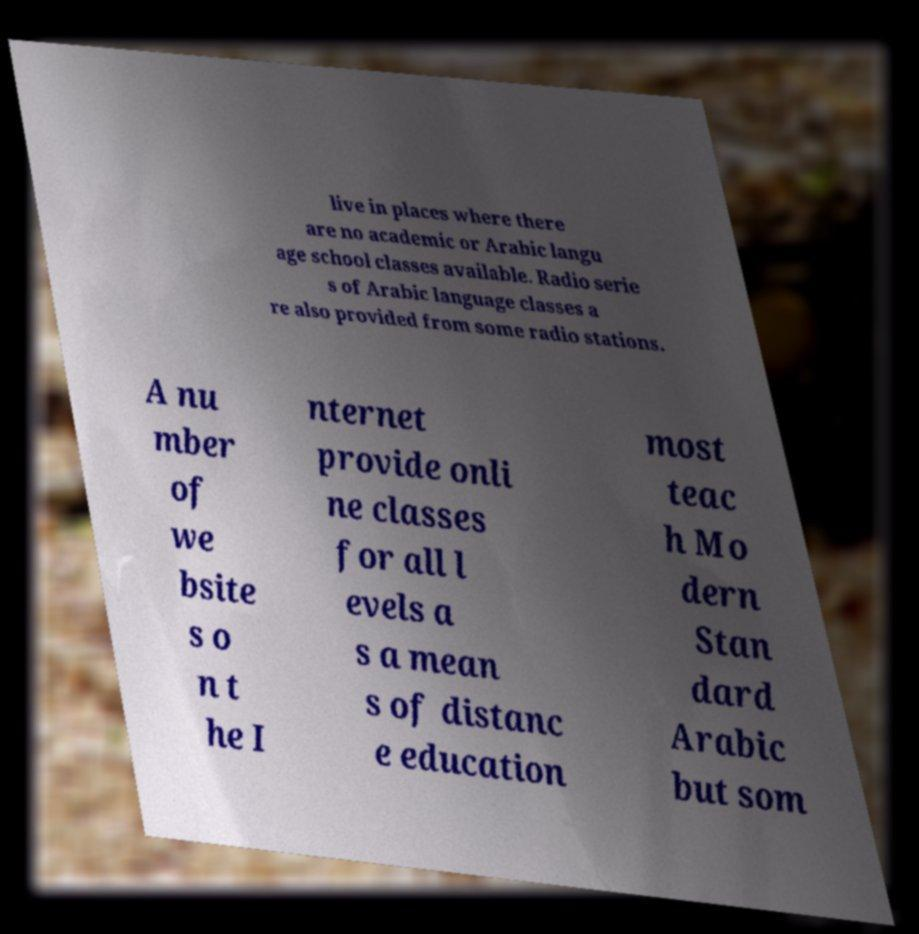What messages or text are displayed in this image? I need them in a readable, typed format. live in places where there are no academic or Arabic langu age school classes available. Radio serie s of Arabic language classes a re also provided from some radio stations. A nu mber of we bsite s o n t he I nternet provide onli ne classes for all l evels a s a mean s of distanc e education most teac h Mo dern Stan dard Arabic but som 